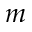Convert formula to latex. <formula><loc_0><loc_0><loc_500><loc_500>m</formula> 